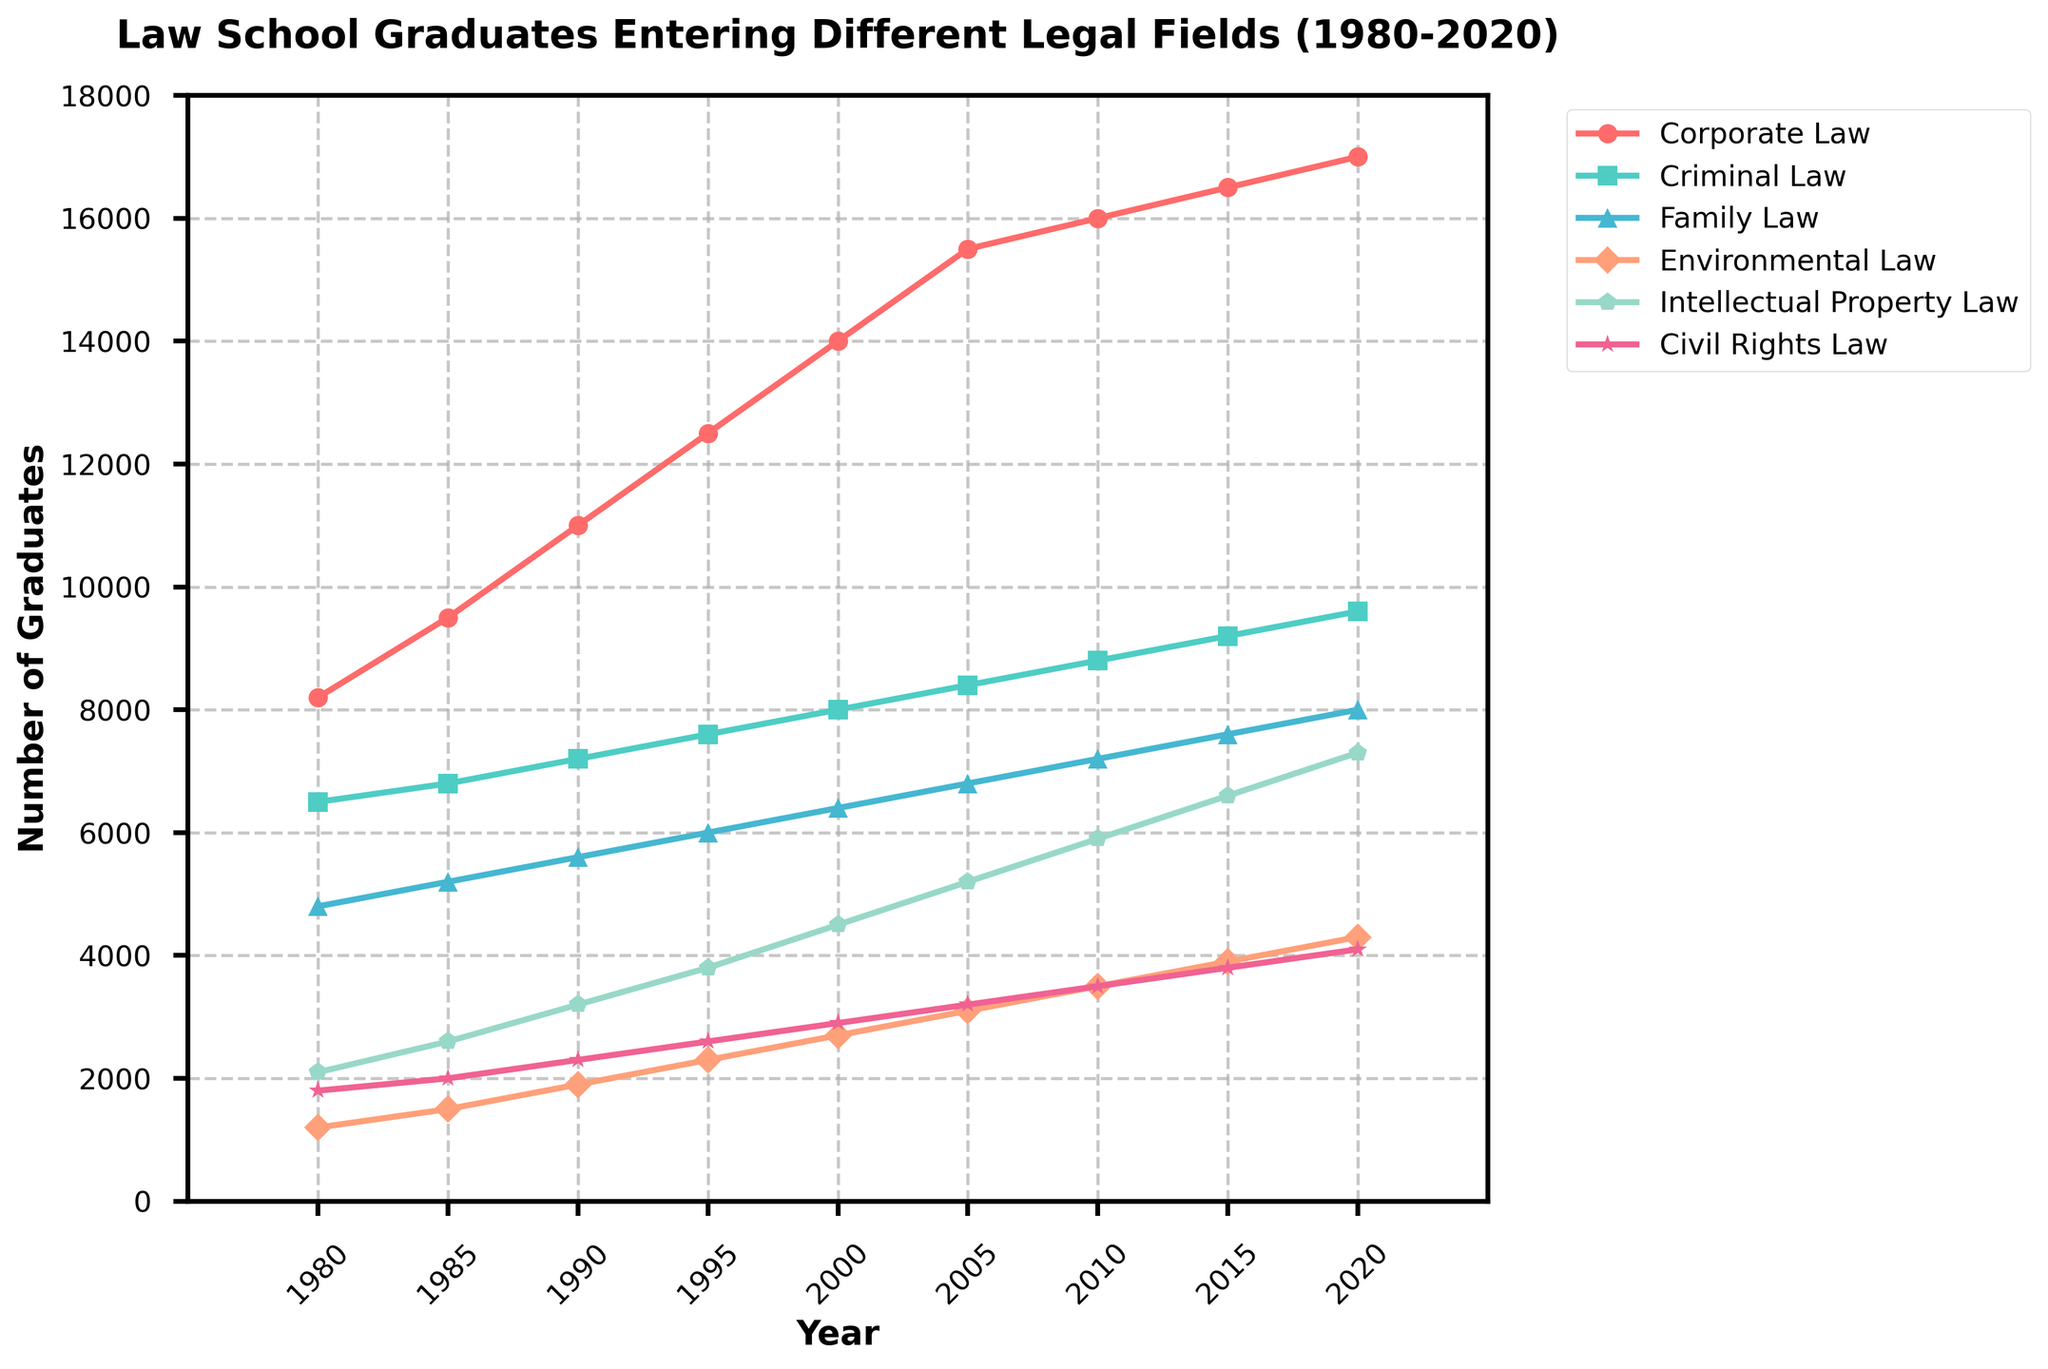What year saw the highest number of law school graduates entering Corporate Law? Look for the data point on the Corporate Law line with the highest value. The peak is at 2020 with 17,000 graduates.
Answer: 2020 Which legal field had the least number of graduates in 1980? Compare the 1980 values for each field: Corporate Law (8,200), Criminal Law (6,500), Family Law (4,800), Environmental Law (1,200), Intellectual Property Law (2,100), Civil Rights Law (1,800). The least is Environmental Law with 1,200 graduates.
Answer: Environmental Law How did the number of graduates in Family Law change from 1980 to 2020? Look at the Family Law values in 1980 (4,800) and 2020 (8,000). Subtract the 1980 value from the 2020 value: 8,000 - 4,800 = 3,200.
Answer: Increased by 3,200 Which two fields showed the most significant growth between 1980 and 2020? Calculate the growth for each field by subtracting the 1980 value from the 2020 value: Corporate Law (8,800), Criminal Law (3,100), Family Law (3,200), Environmental Law (3,100), Intellectual Property Law (5,200), Civil Rights Law (2,300). Corporate Law and Intellectual Property Law showed the most growth.
Answer: Corporate Law, Intellectual Property Law By how much did the number of graduates in Civil Rights Law increase from 1995 to 2020? Look at the Civil Rights Law values in 1995 (2,600) and 2020 (4,100). Subtract the 1995 value from the 2020 value: 4,100 - 2,600 = 1,500.
Answer: 1,500 Between which two consecutive periods did Criminal Law graduates increase the most? Look at the differences between consecutive periods for Criminal Law. The increases are: 1980-1985 (300), 1985-1990 (400), 1990-1995 (400), 1995-2000 (400), 2000-2005 (400), 2005-2010 (400), 2010-2015 (400), 2015-2020 (400). The largest increase happens between 1980-1985 with 300 additional graduates.
Answer: 1980-1985 What is the average number of graduates entering Environmental Law over the 40 years? Add up all the values for Environmental Law and divide by the number of years: (1,200 + 1,500 + 1,900 + 2,300 + 2,700 + 3,100 + 3,500 + 3,900 + 4,300) / 9 = 2,600.
Answer: 2,600 Which year had the closest number of Criminal Law graduates to Family Law graduates? Compare all years’ differences between Criminal Law and Family Law: 1980 (1,700), 1985 (1,600), 1990 (1,600), 1995 (1,600), 2000 (1,600), 2005 (1,600), 2010 (1,600), 2015 (1,600), 2020 (1,600). These values indicate an equal increment in each period. The closest difference is consistent at 2010.
Answer: 2010 